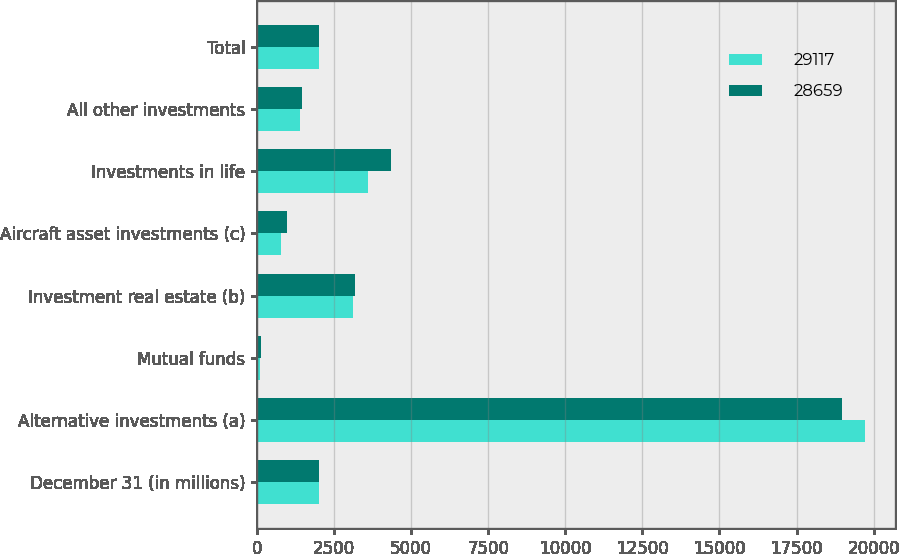Convert chart. <chart><loc_0><loc_0><loc_500><loc_500><stacked_bar_chart><ecel><fcel>December 31 (in millions)<fcel>Alternative investments (a)<fcel>Mutual funds<fcel>Investment real estate (b)<fcel>Aircraft asset investments (c)<fcel>Investments in life<fcel>All other investments<fcel>Total<nl><fcel>29117<fcel>2013<fcel>19709<fcel>85<fcel>3113<fcel>763<fcel>3601<fcel>1388<fcel>2012.5<nl><fcel>28659<fcel>2012<fcel>18990<fcel>128<fcel>3195<fcel>984<fcel>4357<fcel>1463<fcel>2012.5<nl></chart> 